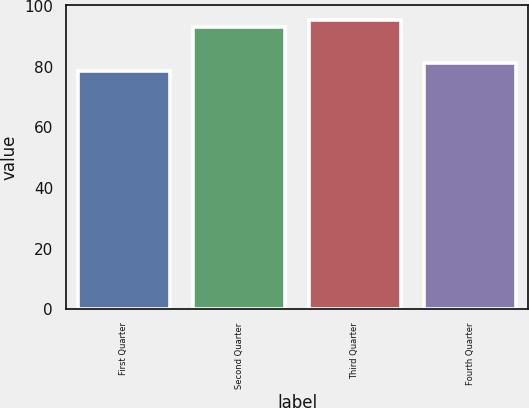<chart> <loc_0><loc_0><loc_500><loc_500><bar_chart><fcel>First Quarter<fcel>Second Quarter<fcel>Third Quarter<fcel>Fourth Quarter<nl><fcel>78.44<fcel>93.09<fcel>95.49<fcel>81.39<nl></chart> 